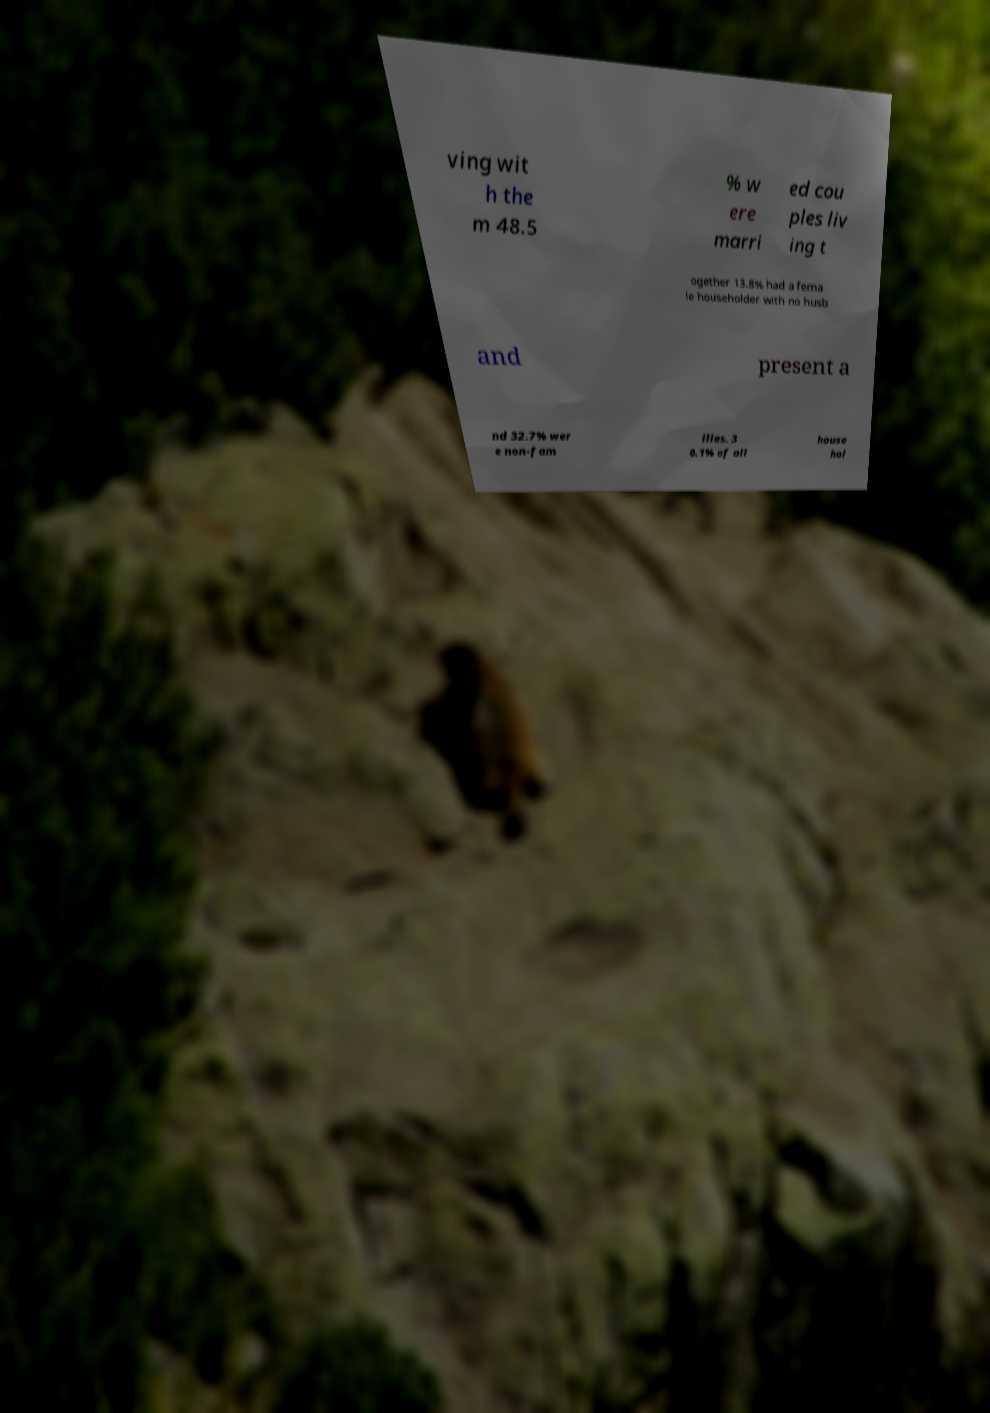Could you extract and type out the text from this image? ving wit h the m 48.5 % w ere marri ed cou ples liv ing t ogether 13.8% had a fema le householder with no husb and present a nd 32.7% wer e non-fam ilies. 3 0.1% of all house hol 